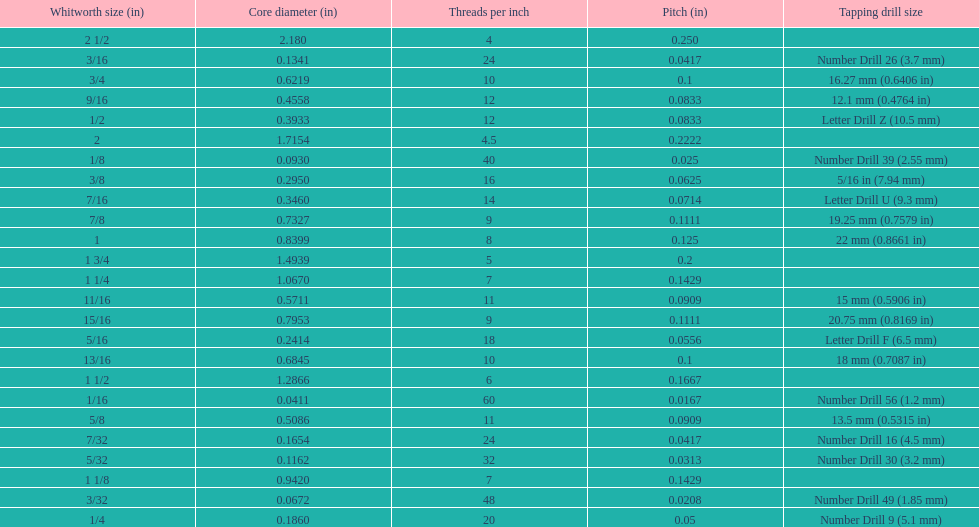Which whitworth size has the same number of threads per inch as 3/16? 7/32. 